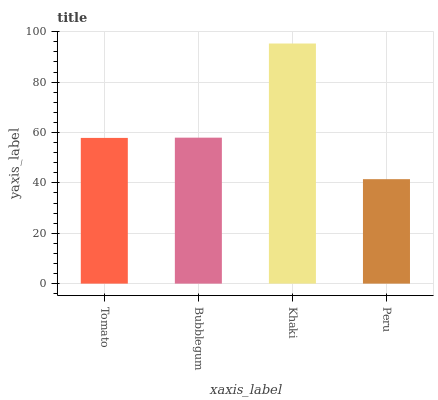Is Bubblegum the minimum?
Answer yes or no. No. Is Bubblegum the maximum?
Answer yes or no. No. Is Bubblegum greater than Tomato?
Answer yes or no. Yes. Is Tomato less than Bubblegum?
Answer yes or no. Yes. Is Tomato greater than Bubblegum?
Answer yes or no. No. Is Bubblegum less than Tomato?
Answer yes or no. No. Is Bubblegum the high median?
Answer yes or no. Yes. Is Tomato the low median?
Answer yes or no. Yes. Is Khaki the high median?
Answer yes or no. No. Is Khaki the low median?
Answer yes or no. No. 